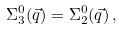Convert formula to latex. <formula><loc_0><loc_0><loc_500><loc_500>\Sigma _ { 3 } ^ { 0 } ( \vec { q } ) = \Sigma _ { 2 } ^ { 0 } ( \vec { q } ) \, ,</formula> 